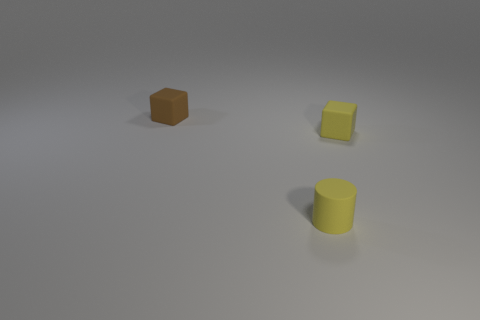Is the number of tiny yellow rubber things less than the number of brown things?
Offer a terse response. No. There is a small cylinder; is it the same color as the small block right of the tiny brown cube?
Ensure brevity in your answer.  Yes. Is the number of yellow rubber blocks that are in front of the small yellow cube the same as the number of blocks on the left side of the small yellow matte cylinder?
Provide a short and direct response. No. What number of red things have the same shape as the brown thing?
Offer a very short reply. 0. Are there any large green shiny cubes?
Offer a terse response. No. There is a yellow cube that is the same size as the cylinder; what is its material?
Your response must be concise. Rubber. Are there any other tiny yellow cubes that have the same material as the tiny yellow block?
Offer a very short reply. No. There is a block that is right of the small cube to the left of the small matte cylinder; is there a rubber object that is in front of it?
Provide a succinct answer. Yes. There is a yellow rubber thing that is the same size as the yellow cylinder; what shape is it?
Provide a succinct answer. Cube. There is a yellow thing right of the cylinder; does it have the same size as the object that is left of the tiny cylinder?
Make the answer very short. Yes. 